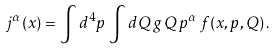<formula> <loc_0><loc_0><loc_500><loc_500>j ^ { \alpha } ( x ) = \int d ^ { 4 } p \, \int d Q \, g \, Q \, p ^ { \alpha } \, f ( x , p , Q ) \, .</formula> 